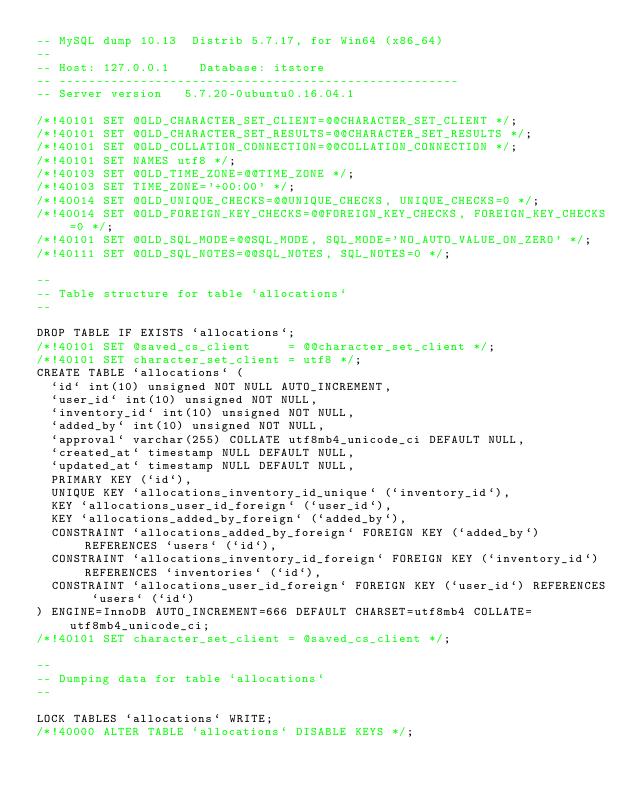Convert code to text. <code><loc_0><loc_0><loc_500><loc_500><_SQL_>-- MySQL dump 10.13  Distrib 5.7.17, for Win64 (x86_64)
--
-- Host: 127.0.0.1    Database: itstore
-- ------------------------------------------------------
-- Server version	5.7.20-0ubuntu0.16.04.1

/*!40101 SET @OLD_CHARACTER_SET_CLIENT=@@CHARACTER_SET_CLIENT */;
/*!40101 SET @OLD_CHARACTER_SET_RESULTS=@@CHARACTER_SET_RESULTS */;
/*!40101 SET @OLD_COLLATION_CONNECTION=@@COLLATION_CONNECTION */;
/*!40101 SET NAMES utf8 */;
/*!40103 SET @OLD_TIME_ZONE=@@TIME_ZONE */;
/*!40103 SET TIME_ZONE='+00:00' */;
/*!40014 SET @OLD_UNIQUE_CHECKS=@@UNIQUE_CHECKS, UNIQUE_CHECKS=0 */;
/*!40014 SET @OLD_FOREIGN_KEY_CHECKS=@@FOREIGN_KEY_CHECKS, FOREIGN_KEY_CHECKS=0 */;
/*!40101 SET @OLD_SQL_MODE=@@SQL_MODE, SQL_MODE='NO_AUTO_VALUE_ON_ZERO' */;
/*!40111 SET @OLD_SQL_NOTES=@@SQL_NOTES, SQL_NOTES=0 */;

--
-- Table structure for table `allocations`
--

DROP TABLE IF EXISTS `allocations`;
/*!40101 SET @saved_cs_client     = @@character_set_client */;
/*!40101 SET character_set_client = utf8 */;
CREATE TABLE `allocations` (
  `id` int(10) unsigned NOT NULL AUTO_INCREMENT,
  `user_id` int(10) unsigned NOT NULL,
  `inventory_id` int(10) unsigned NOT NULL,
  `added_by` int(10) unsigned NOT NULL,
  `approval` varchar(255) COLLATE utf8mb4_unicode_ci DEFAULT NULL,
  `created_at` timestamp NULL DEFAULT NULL,
  `updated_at` timestamp NULL DEFAULT NULL,
  PRIMARY KEY (`id`),
  UNIQUE KEY `allocations_inventory_id_unique` (`inventory_id`),
  KEY `allocations_user_id_foreign` (`user_id`),
  KEY `allocations_added_by_foreign` (`added_by`),
  CONSTRAINT `allocations_added_by_foreign` FOREIGN KEY (`added_by`) REFERENCES `users` (`id`),
  CONSTRAINT `allocations_inventory_id_foreign` FOREIGN KEY (`inventory_id`) REFERENCES `inventories` (`id`),
  CONSTRAINT `allocations_user_id_foreign` FOREIGN KEY (`user_id`) REFERENCES `users` (`id`)
) ENGINE=InnoDB AUTO_INCREMENT=666 DEFAULT CHARSET=utf8mb4 COLLATE=utf8mb4_unicode_ci;
/*!40101 SET character_set_client = @saved_cs_client */;

--
-- Dumping data for table `allocations`
--

LOCK TABLES `allocations` WRITE;
/*!40000 ALTER TABLE `allocations` DISABLE KEYS */;</code> 